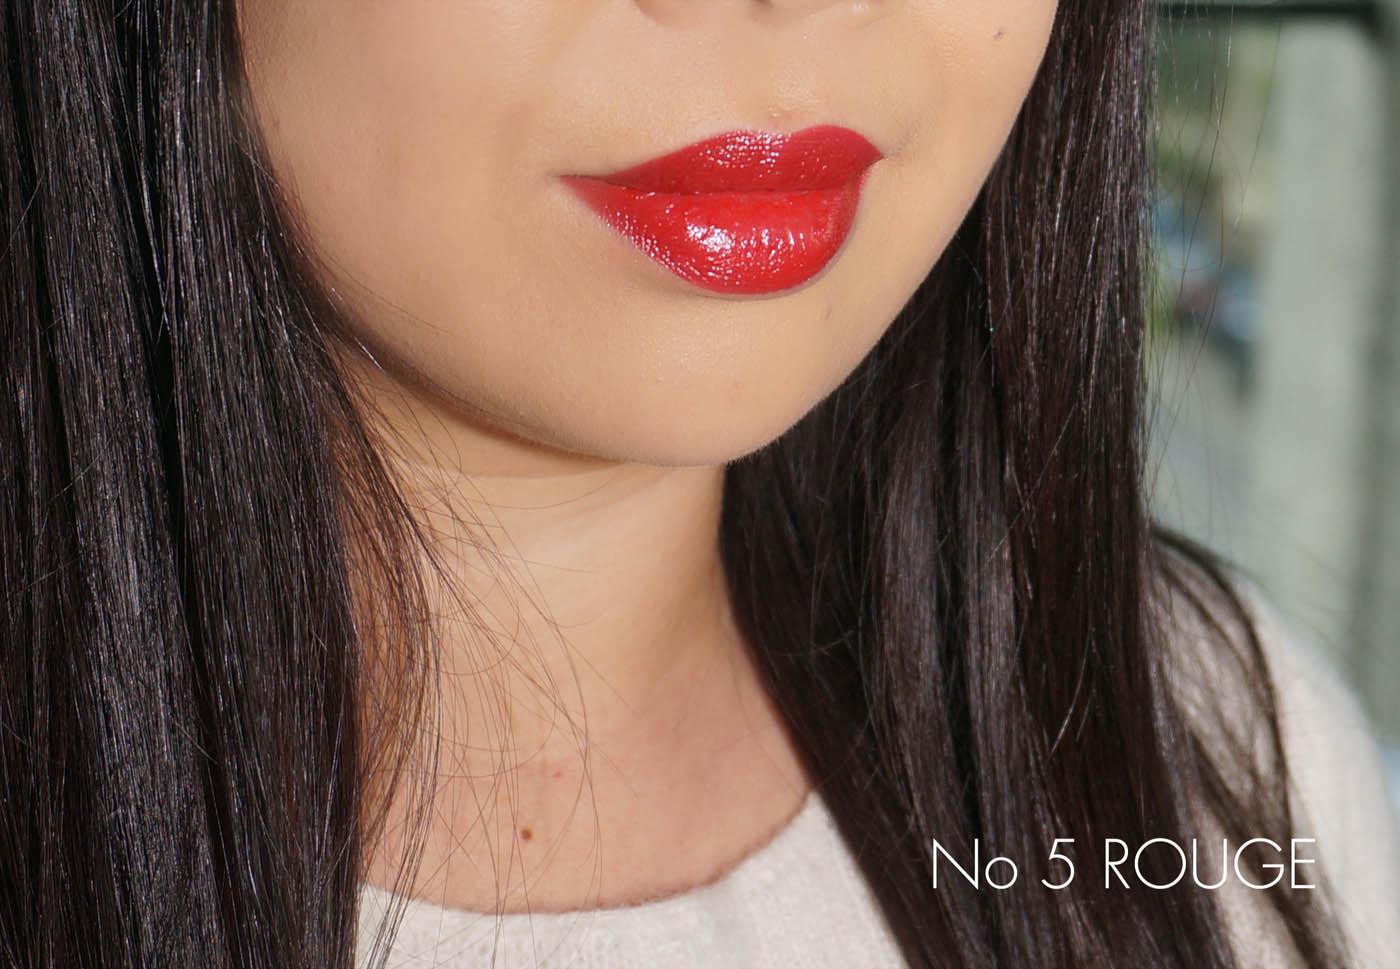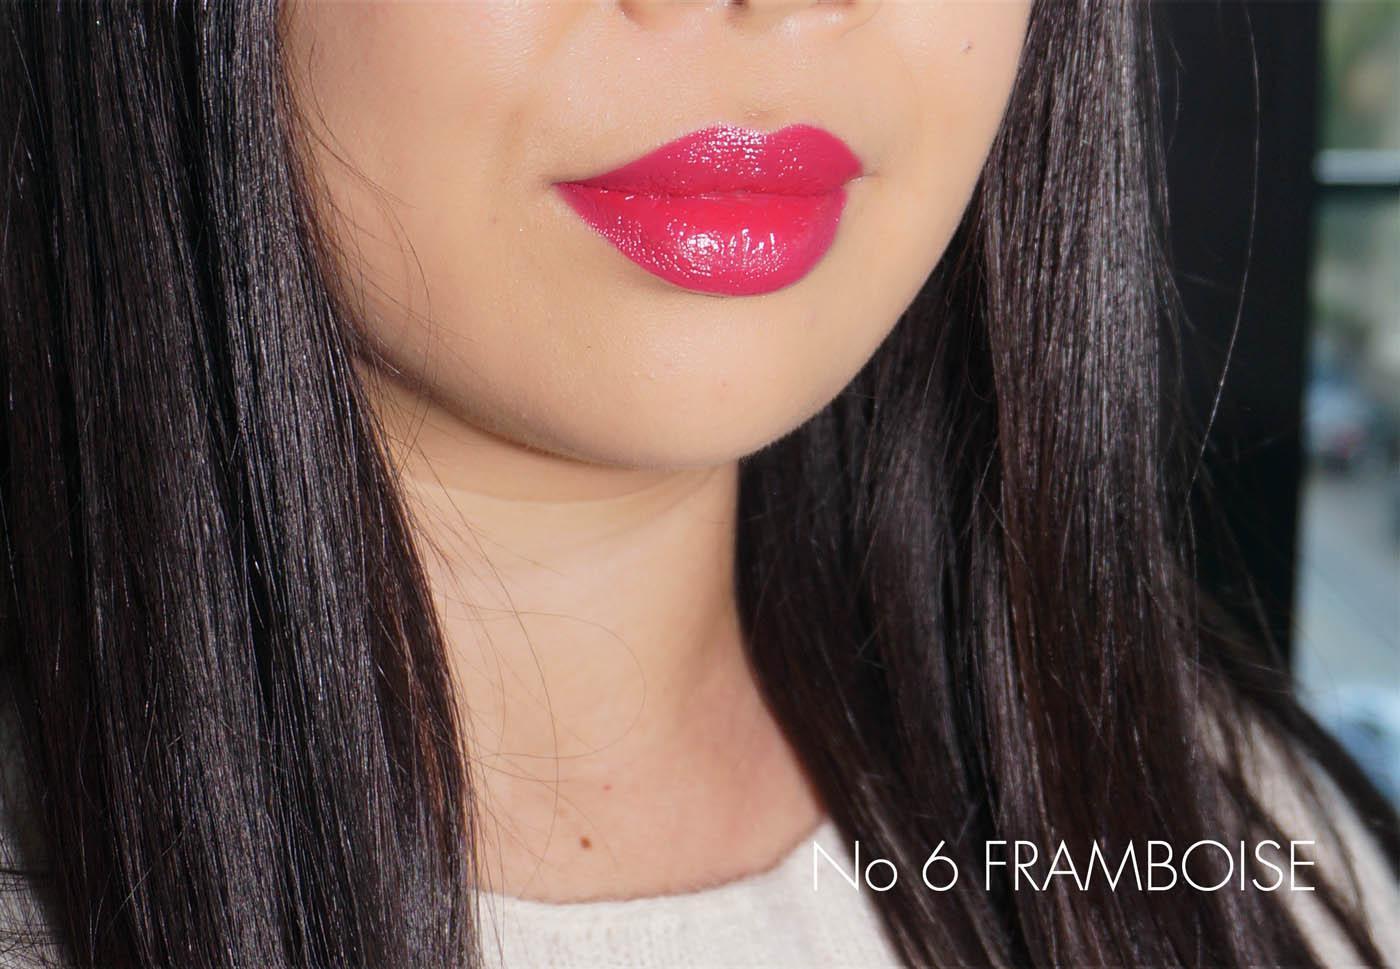The first image is the image on the left, the second image is the image on the right. For the images shown, is this caption "Both images show a brunette model with tinted, closed lips, and both models wear a pale top with a round neckline." true? Answer yes or no. Yes. 